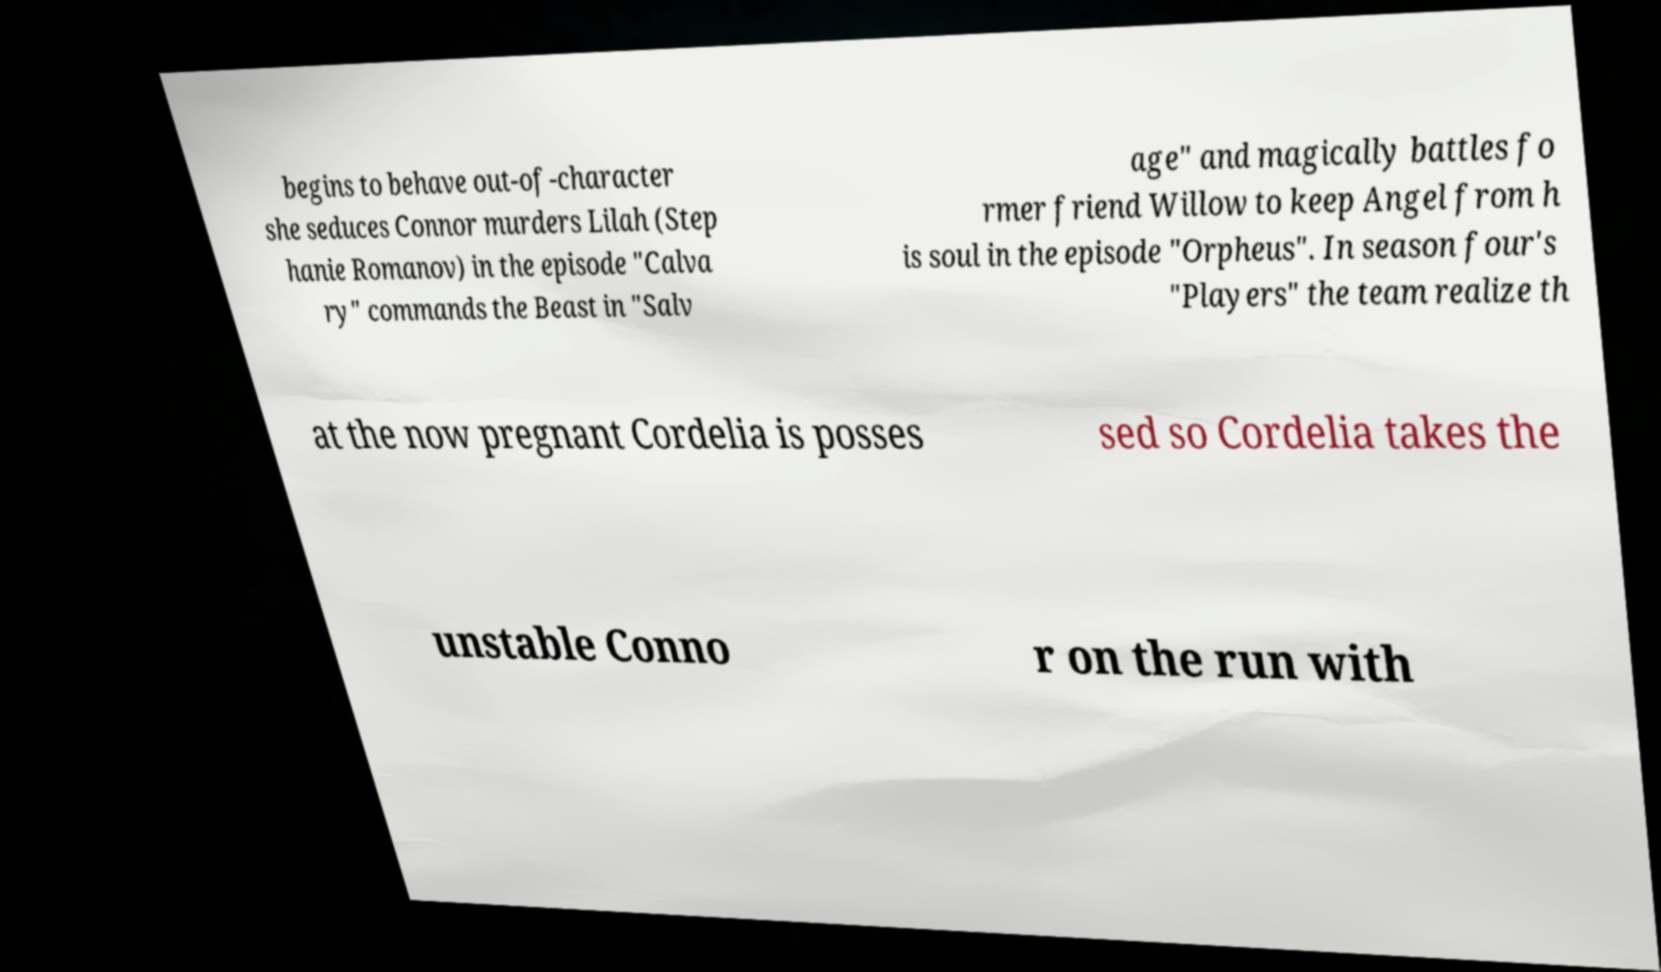I need the written content from this picture converted into text. Can you do that? begins to behave out-of-character she seduces Connor murders Lilah (Step hanie Romanov) in the episode "Calva ry" commands the Beast in "Salv age" and magically battles fo rmer friend Willow to keep Angel from h is soul in the episode "Orpheus". In season four's "Players" the team realize th at the now pregnant Cordelia is posses sed so Cordelia takes the unstable Conno r on the run with 